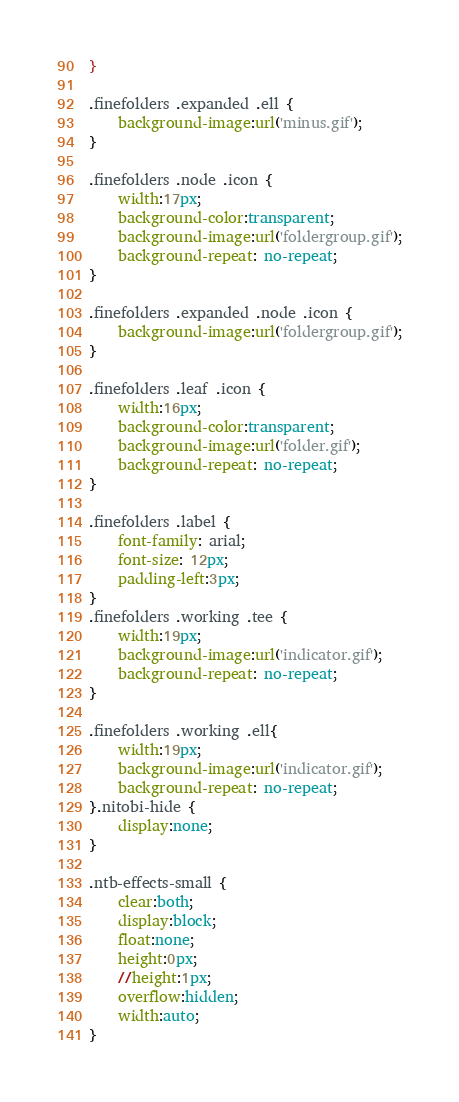Convert code to text. <code><loc_0><loc_0><loc_500><loc_500><_CSS_>}

.finefolders .expanded .ell {
	background-image:url('minus.gif');
}

.finefolders .node .icon {
	width:17px;
	background-color:transparent;
	background-image:url('foldergroup.gif');
	background-repeat: no-repeat;
}

.finefolders .expanded .node .icon {
	background-image:url('foldergroup.gif');
}

.finefolders .leaf .icon {
	width:16px;
	background-color:transparent;
	background-image:url('folder.gif');
	background-repeat: no-repeat;
}

.finefolders .label {
	font-family: arial;
	font-size: 12px;
	padding-left:3px;
}
.finefolders .working .tee {
	width:19px;
	background-image:url('indicator.gif');
	background-repeat: no-repeat;
}

.finefolders .working .ell{
	width:19px;
	background-image:url('indicator.gif');
	background-repeat: no-repeat;
}.nitobi-hide {
	display:none;
}

.ntb-effects-small {
	clear:both;
	display:block;
	float:none;
	height:0px;
	//height:1px;
	overflow:hidden;
	width:auto;
}</code> 